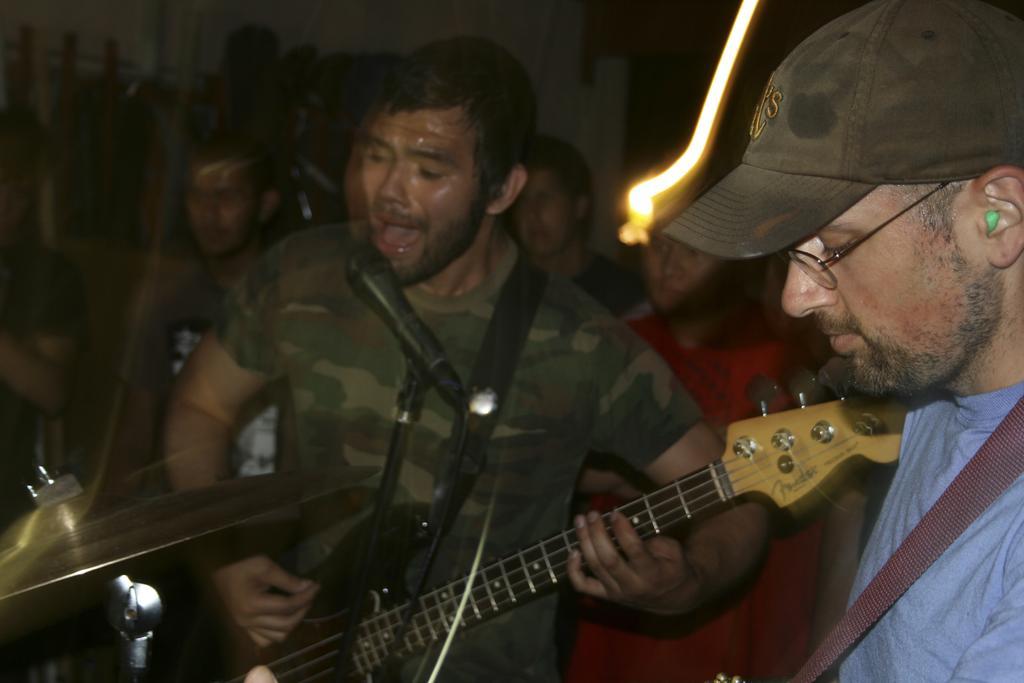Can you describe this image briefly? Here we can see the man in the middle playing guitar and singing song with microphone in front of him and the man in the right side is playing some other musical instrument and here we can see cymbal plates present in behind them we can see some people sitting 